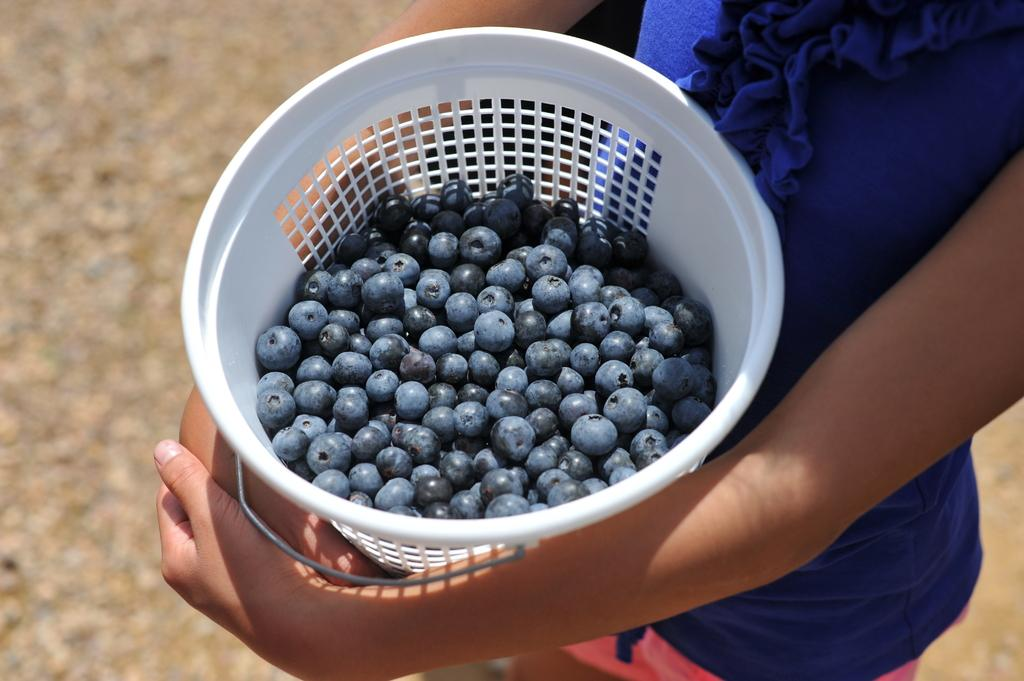Who is the main subject in the image? There is a girl in the image. What is the girl holding in the image? The girl is holding a basket. What color is the top that the girl is wearing? The girl is wearing a blue color top. What is inside the basket that the girl is holding? There are grapes in the basket. What can be seen in the background of the image? There is land visible in the background of the image. What type of ring can be seen on the girl's finger in the image? There is no ring visible on the girl's finger in the image. 